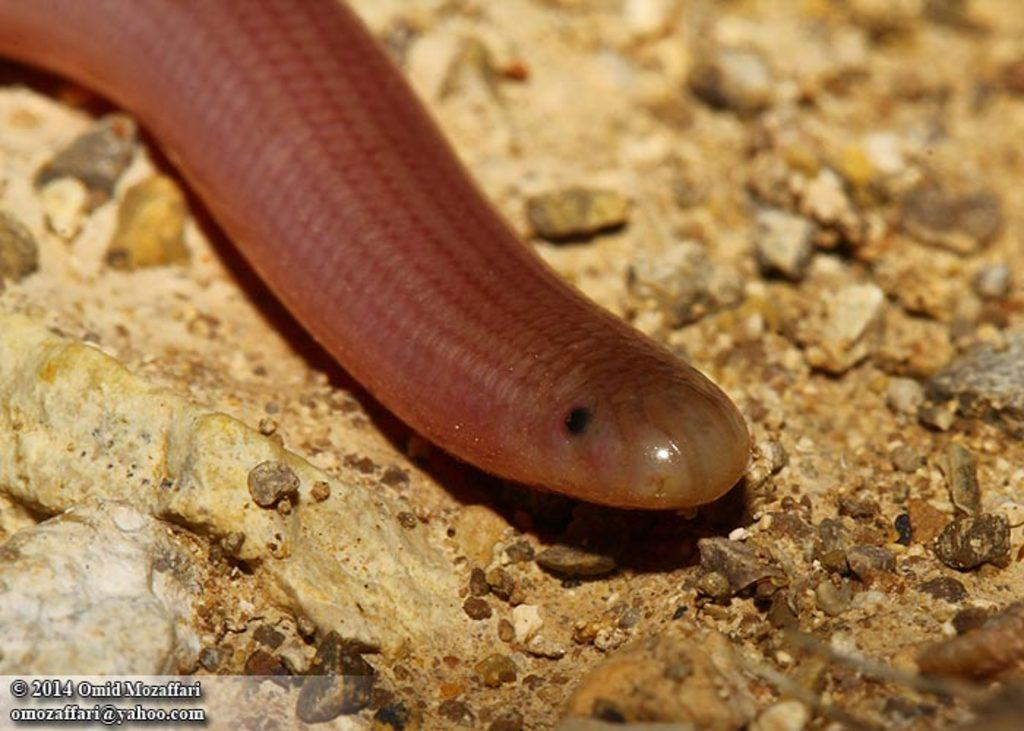What type of creature is in the picture? There is a slug in the picture. What color is the slug? The slug is brown in color. What can be seen at the bottom of the picture? There is a rock and small stones at the bottom of the picture. What type of thing is being baked in the oven in the image? There is no oven present in the image, and therefore no baking activity can be observed. What type of structure can be seen in the background of the image? There is no structure visible in the image; it primarily features a slug and some stones. 